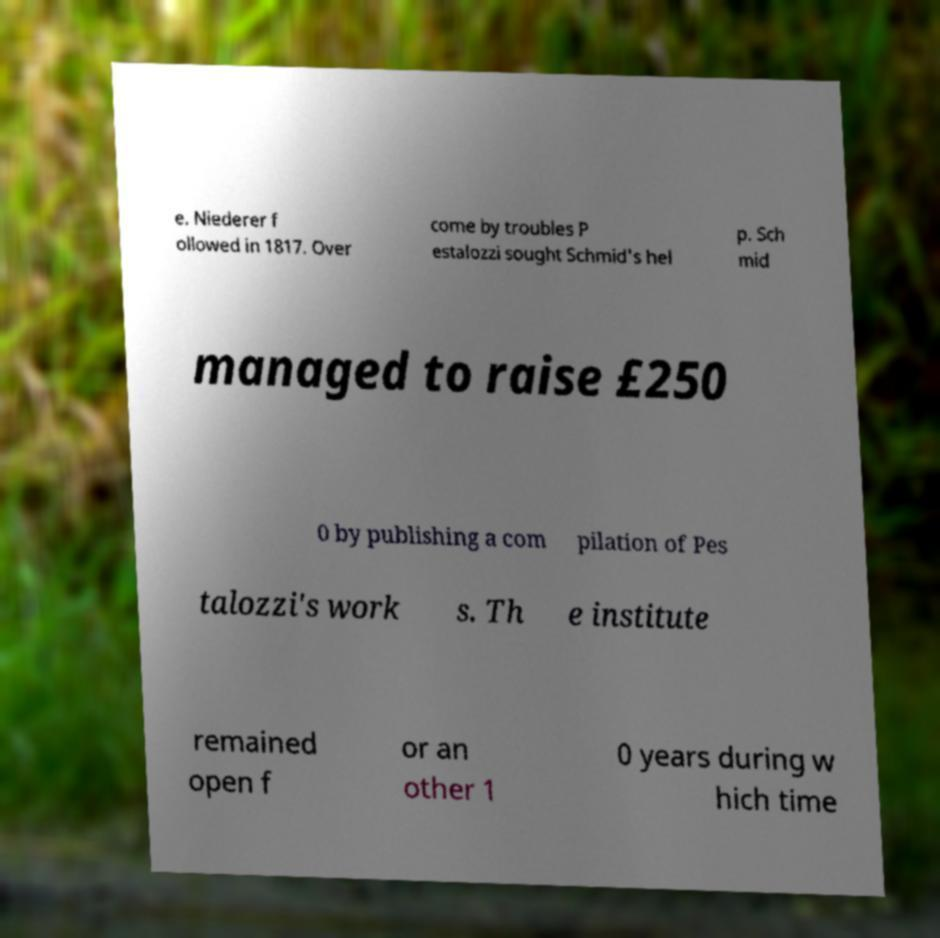There's text embedded in this image that I need extracted. Can you transcribe it verbatim? e. Niederer f ollowed in 1817. Over come by troubles P estalozzi sought Schmid's hel p. Sch mid managed to raise £250 0 by publishing a com pilation of Pes talozzi's work s. Th e institute remained open f or an other 1 0 years during w hich time 